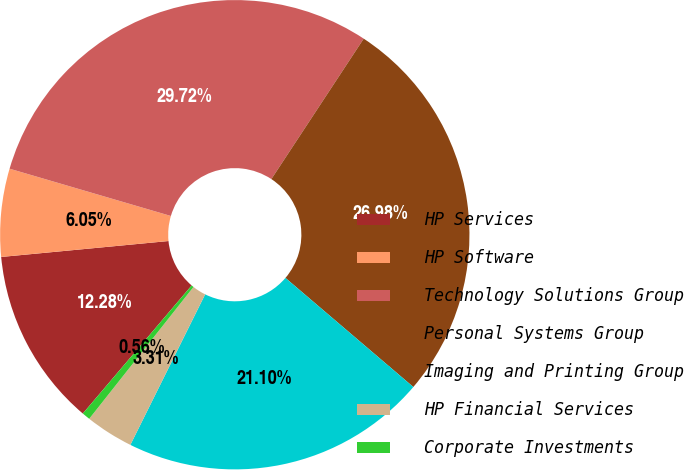<chart> <loc_0><loc_0><loc_500><loc_500><pie_chart><fcel>HP Services<fcel>HP Software<fcel>Technology Solutions Group<fcel>Personal Systems Group<fcel>Imaging and Printing Group<fcel>HP Financial Services<fcel>Corporate Investments<nl><fcel>12.28%<fcel>6.05%<fcel>29.72%<fcel>26.98%<fcel>21.1%<fcel>3.31%<fcel>0.56%<nl></chart> 